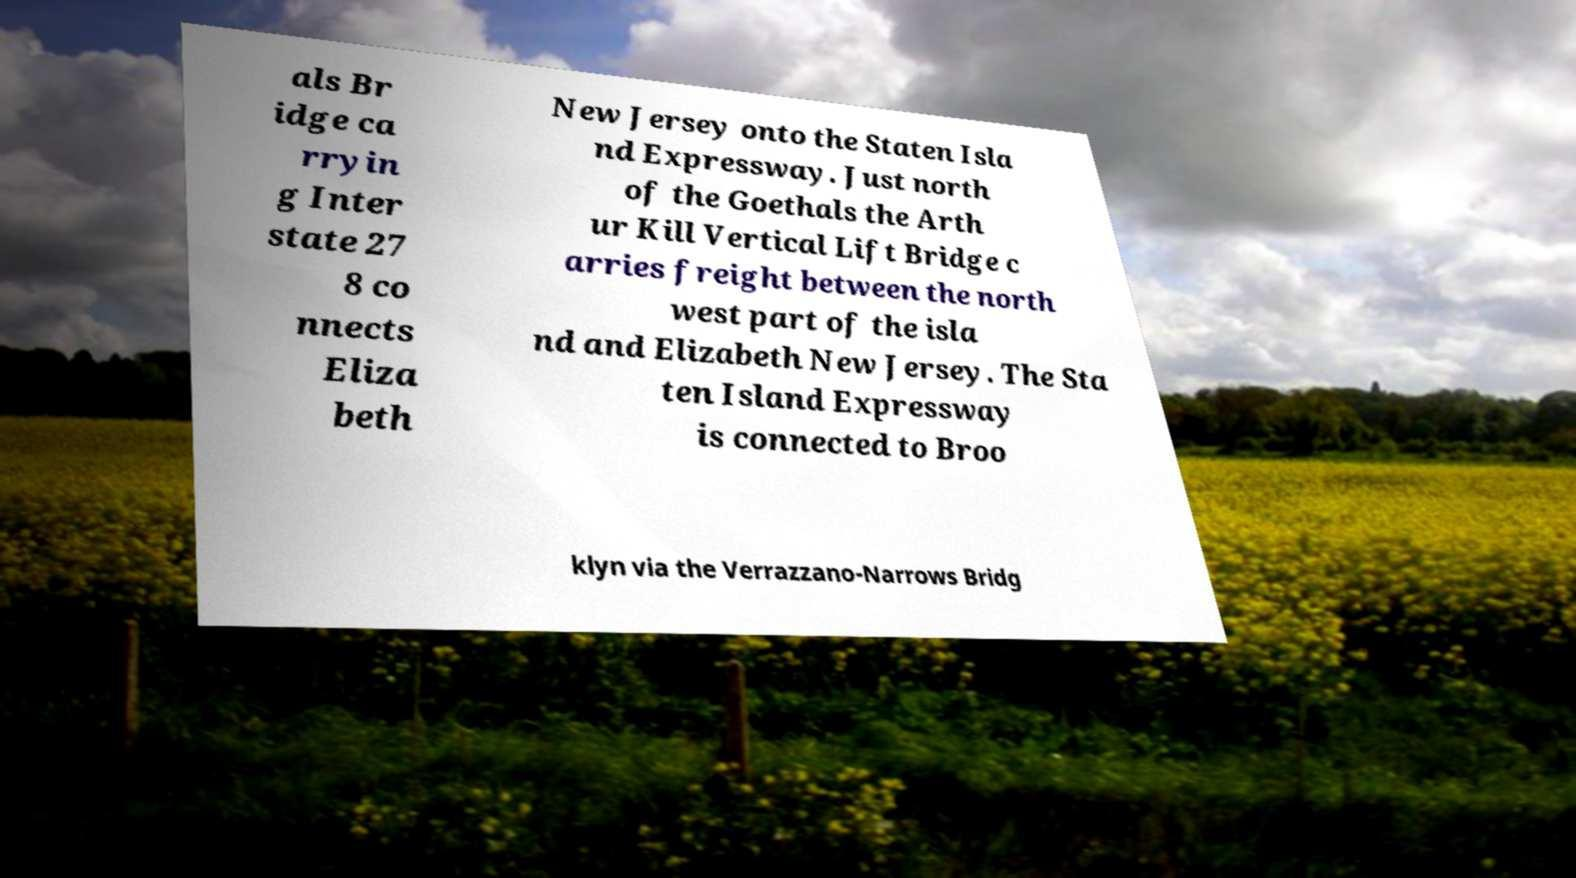Could you extract and type out the text from this image? als Br idge ca rryin g Inter state 27 8 co nnects Eliza beth New Jersey onto the Staten Isla nd Expressway. Just north of the Goethals the Arth ur Kill Vertical Lift Bridge c arries freight between the north west part of the isla nd and Elizabeth New Jersey. The Sta ten Island Expressway is connected to Broo klyn via the Verrazzano-Narrows Bridg 